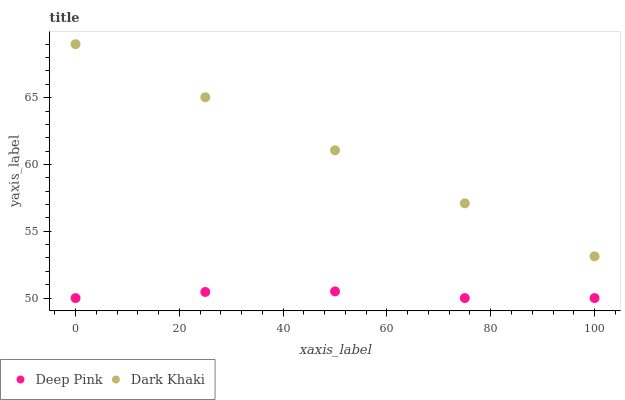Does Deep Pink have the minimum area under the curve?
Answer yes or no. Yes. Does Dark Khaki have the maximum area under the curve?
Answer yes or no. Yes. Does Deep Pink have the maximum area under the curve?
Answer yes or no. No. Is Dark Khaki the smoothest?
Answer yes or no. Yes. Is Deep Pink the roughest?
Answer yes or no. Yes. Is Deep Pink the smoothest?
Answer yes or no. No. Does Deep Pink have the lowest value?
Answer yes or no. Yes. Does Dark Khaki have the highest value?
Answer yes or no. Yes. Does Deep Pink have the highest value?
Answer yes or no. No. Is Deep Pink less than Dark Khaki?
Answer yes or no. Yes. Is Dark Khaki greater than Deep Pink?
Answer yes or no. Yes. Does Deep Pink intersect Dark Khaki?
Answer yes or no. No. 